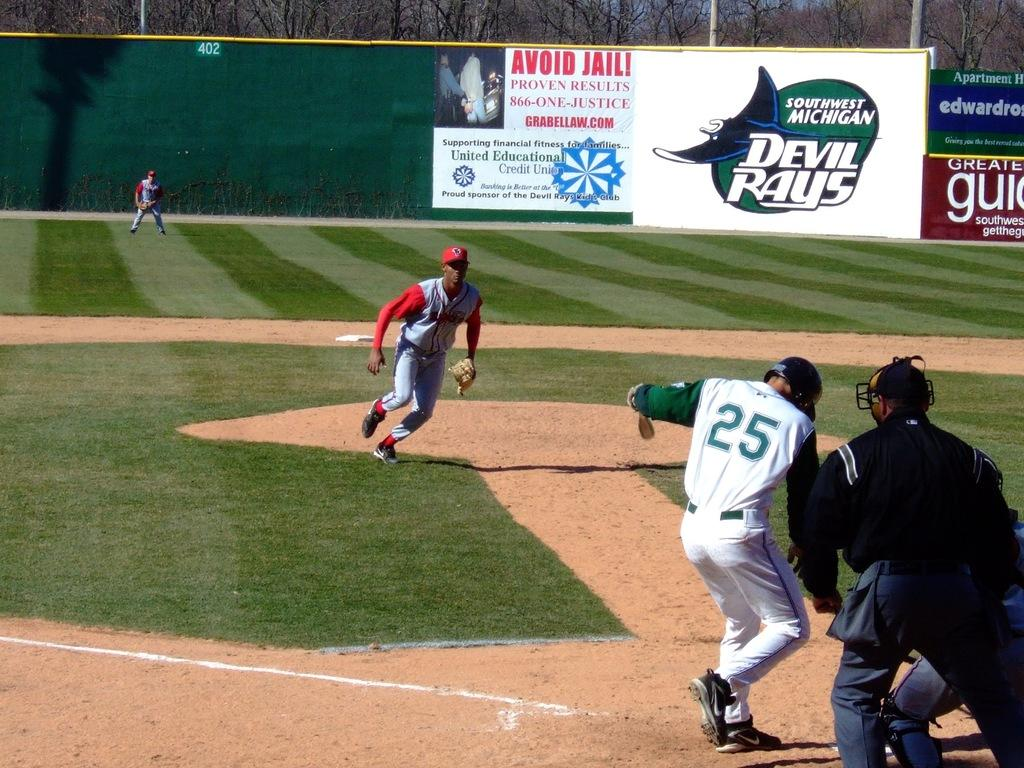<image>
Render a clear and concise summary of the photo. A baseball player with 25 on his jersey kicking at dust. 